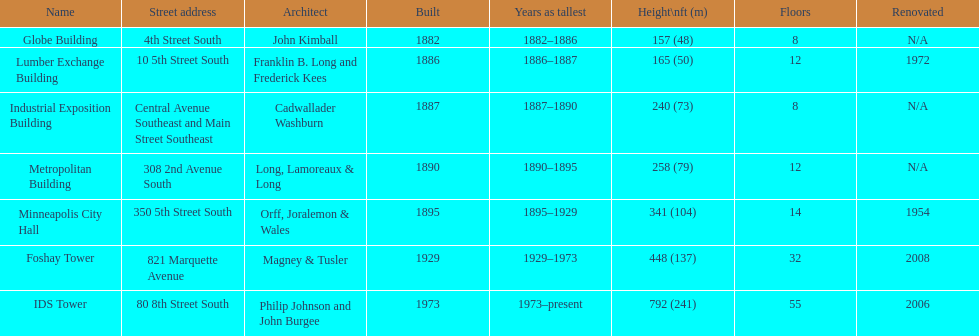How long did the lumber exchange building stand as the tallest building? 1 year. 